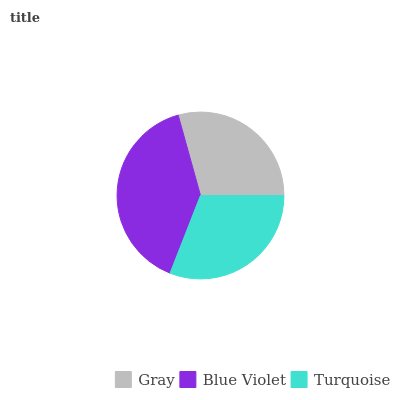Is Gray the minimum?
Answer yes or no. Yes. Is Blue Violet the maximum?
Answer yes or no. Yes. Is Turquoise the minimum?
Answer yes or no. No. Is Turquoise the maximum?
Answer yes or no. No. Is Blue Violet greater than Turquoise?
Answer yes or no. Yes. Is Turquoise less than Blue Violet?
Answer yes or no. Yes. Is Turquoise greater than Blue Violet?
Answer yes or no. No. Is Blue Violet less than Turquoise?
Answer yes or no. No. Is Turquoise the high median?
Answer yes or no. Yes. Is Turquoise the low median?
Answer yes or no. Yes. Is Gray the high median?
Answer yes or no. No. Is Blue Violet the low median?
Answer yes or no. No. 